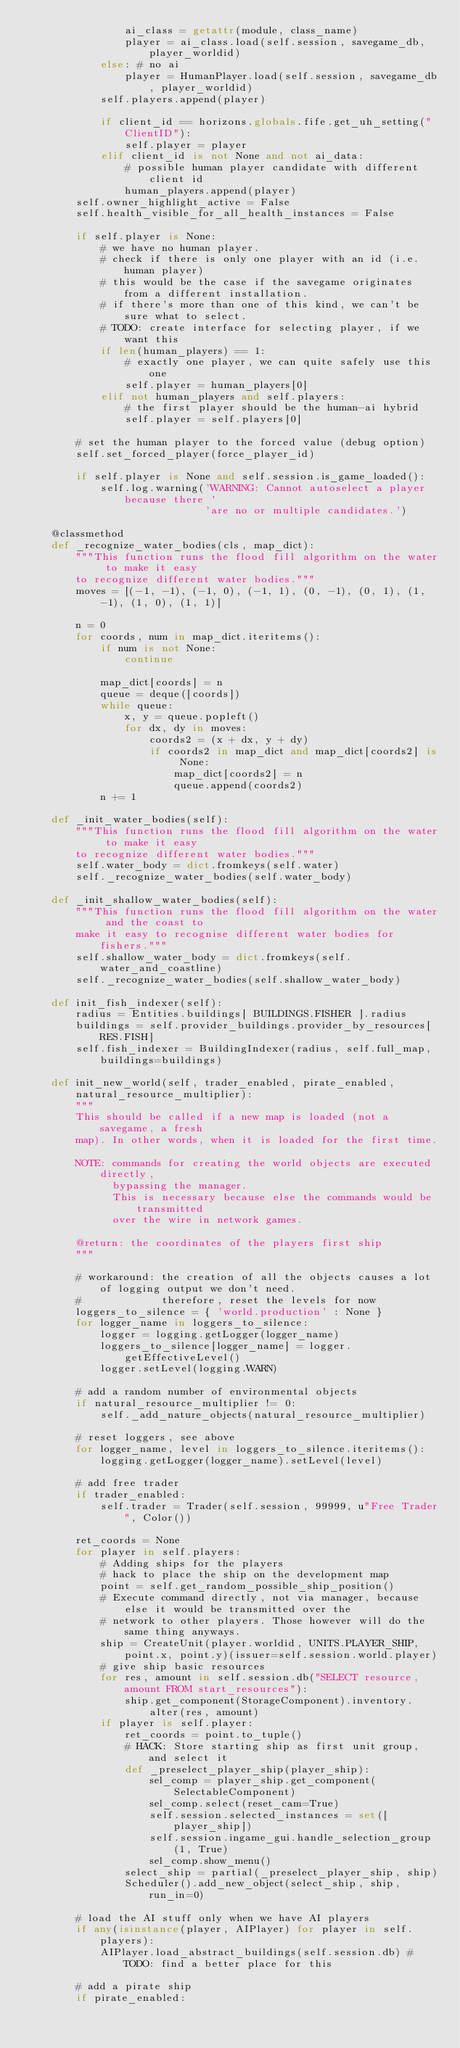<code> <loc_0><loc_0><loc_500><loc_500><_Python_>				ai_class = getattr(module, class_name)
				player = ai_class.load(self.session, savegame_db, player_worldid)
			else: # no ai
				player = HumanPlayer.load(self.session, savegame_db, player_worldid)
			self.players.append(player)

			if client_id == horizons.globals.fife.get_uh_setting("ClientID"):
				self.player = player
			elif client_id is not None and not ai_data:
				# possible human player candidate with different client id
				human_players.append(player)
		self.owner_highlight_active = False
		self.health_visible_for_all_health_instances = False

		if self.player is None:
			# we have no human player.
			# check if there is only one player with an id (i.e. human player)
			# this would be the case if the savegame originates from a different installation.
			# if there's more than one of this kind, we can't be sure what to select.
			# TODO: create interface for selecting player, if we want this
			if len(human_players) == 1:
				# exactly one player, we can quite safely use this one
				self.player = human_players[0]
			elif not human_players and self.players:
				# the first player should be the human-ai hybrid
				self.player = self.players[0]

		# set the human player to the forced value (debug option)
		self.set_forced_player(force_player_id)

		if self.player is None and self.session.is_game_loaded():
			self.log.warning('WARNING: Cannot autoselect a player because there '
			                 'are no or multiple candidates.')

	@classmethod
	def _recognize_water_bodies(cls, map_dict):
		"""This function runs the flood fill algorithm on the water to make it easy
		to recognize different water bodies."""
		moves = [(-1, -1), (-1, 0), (-1, 1), (0, -1), (0, 1), (1, -1), (1, 0), (1, 1)]

		n = 0
		for coords, num in map_dict.iteritems():
			if num is not None:
				continue

			map_dict[coords] = n
			queue = deque([coords])
			while queue:
				x, y = queue.popleft()
				for dx, dy in moves:
					coords2 = (x + dx, y + dy)
					if coords2 in map_dict and map_dict[coords2] is None:
						map_dict[coords2] = n
						queue.append(coords2)
			n += 1

	def _init_water_bodies(self):
		"""This function runs the flood fill algorithm on the water to make it easy
		to recognize different water bodies."""
		self.water_body = dict.fromkeys(self.water)
		self._recognize_water_bodies(self.water_body)

	def _init_shallow_water_bodies(self):
		"""This function runs the flood fill algorithm on the water and the coast to
		make it easy to recognise different water bodies for fishers."""
		self.shallow_water_body = dict.fromkeys(self.water_and_coastline)
		self._recognize_water_bodies(self.shallow_water_body)

	def init_fish_indexer(self):
		radius = Entities.buildings[ BUILDINGS.FISHER ].radius
		buildings = self.provider_buildings.provider_by_resources[RES.FISH]
		self.fish_indexer = BuildingIndexer(radius, self.full_map, buildings=buildings)

	def init_new_world(self, trader_enabled, pirate_enabled, natural_resource_multiplier):
		"""
		This should be called if a new map is loaded (not a savegame, a fresh
		map). In other words, when it is loaded for the first time.

		NOTE: commands for creating the world objects are executed directly,
		      bypassing the manager.
		      This is necessary because else the commands would be transmitted
		      over the wire in network games.

		@return: the coordinates of the players first ship
		"""

		# workaround: the creation of all the objects causes a lot of logging output we don't need.
		#             therefore, reset the levels for now
		loggers_to_silence = { 'world.production' : None }
		for logger_name in loggers_to_silence:
			logger = logging.getLogger(logger_name)
			loggers_to_silence[logger_name] = logger.getEffectiveLevel()
			logger.setLevel(logging.WARN)

		# add a random number of environmental objects
		if natural_resource_multiplier != 0:
			self._add_nature_objects(natural_resource_multiplier)

		# reset loggers, see above
		for logger_name, level in loggers_to_silence.iteritems():
			logging.getLogger(logger_name).setLevel(level)

		# add free trader
		if trader_enabled:
			self.trader = Trader(self.session, 99999, u"Free Trader", Color())

		ret_coords = None
		for player in self.players:
			# Adding ships for the players
			# hack to place the ship on the development map
			point = self.get_random_possible_ship_position()
			# Execute command directly, not via manager, because else it would be transmitted over the
			# network to other players. Those however will do the same thing anyways.
			ship = CreateUnit(player.worldid, UNITS.PLAYER_SHIP, point.x, point.y)(issuer=self.session.world.player)
			# give ship basic resources
			for res, amount in self.session.db("SELECT resource, amount FROM start_resources"):
				ship.get_component(StorageComponent).inventory.alter(res, amount)
			if player is self.player:
				ret_coords = point.to_tuple()
				# HACK: Store starting ship as first unit group, and select it
				def _preselect_player_ship(player_ship):
					sel_comp = player_ship.get_component(SelectableComponent)
					sel_comp.select(reset_cam=True)
					self.session.selected_instances = set([player_ship])
					self.session.ingame_gui.handle_selection_group(1, True)
					sel_comp.show_menu()
				select_ship = partial(_preselect_player_ship, ship)
				Scheduler().add_new_object(select_ship, ship, run_in=0)

		# load the AI stuff only when we have AI players
		if any(isinstance(player, AIPlayer) for player in self.players):
			AIPlayer.load_abstract_buildings(self.session.db) # TODO: find a better place for this

		# add a pirate ship
		if pirate_enabled:</code> 